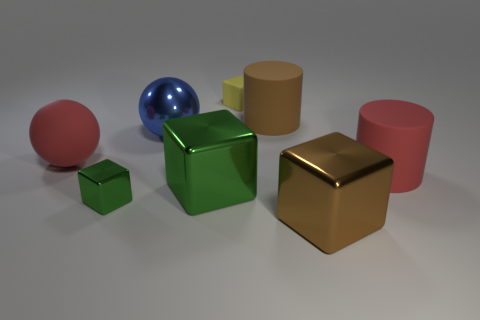Add 1 metal blocks. How many objects exist? 9 Subtract all tiny yellow rubber cubes. How many cubes are left? 3 Subtract all brown cylinders. How many cylinders are left? 1 Subtract all cylinders. How many objects are left? 6 Subtract 1 brown cylinders. How many objects are left? 7 Subtract 1 spheres. How many spheres are left? 1 Subtract all brown spheres. Subtract all blue blocks. How many spheres are left? 2 Subtract all red blocks. How many blue balls are left? 1 Subtract all large gray spheres. Subtract all big objects. How many objects are left? 2 Add 8 blue balls. How many blue balls are left? 9 